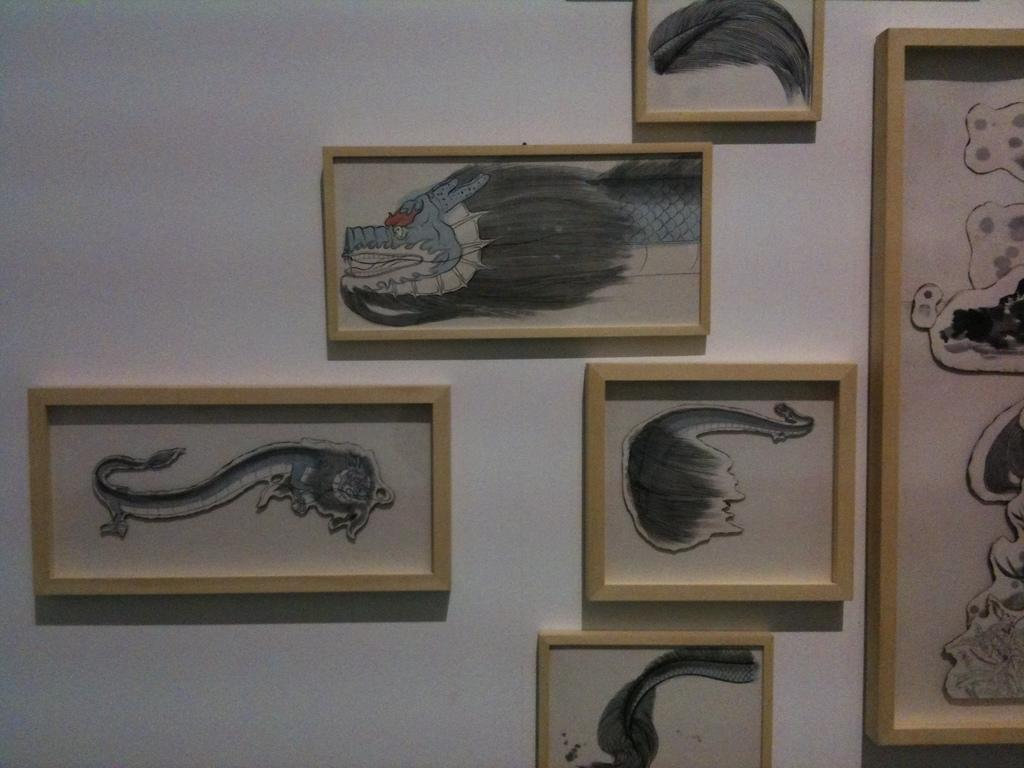What objects are visible in the image? There are photo frames in the image. Where are the photo frames located? The photo frames are attached to a wall. What might be contained within the photo frames? The photo frames likely contain paintings. What is the color of the wall in the image? The wall is white in color. What type of cheese is being shared among the group in the image? There is no cheese or group present in the image; it only features photo frames attached to a white wall. 